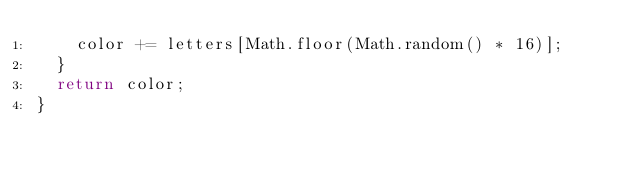<code> <loc_0><loc_0><loc_500><loc_500><_TypeScript_>    color += letters[Math.floor(Math.random() * 16)];
  }
  return color;
}
</code> 